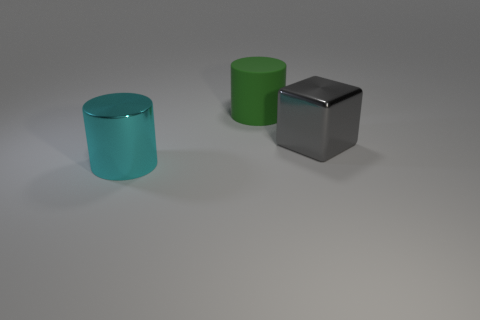What color is the big metal thing that is behind the large metallic cylinder?
Your answer should be very brief. Gray. What shape is the cyan metallic object that is the same size as the gray thing?
Ensure brevity in your answer.  Cylinder. What number of things are large things that are left of the large matte thing or large objects behind the large cyan metal cylinder?
Provide a succinct answer. 3. What material is the green thing that is the same size as the metal block?
Offer a terse response. Rubber. How many other objects are there of the same material as the big gray object?
Give a very brief answer. 1. There is a metallic thing that is on the left side of the big gray cube; is its shape the same as the large green rubber thing behind the big cube?
Offer a terse response. Yes. There is a shiny thing behind the shiny thing that is to the left of the object that is on the right side of the green cylinder; what color is it?
Give a very brief answer. Gray. Is the number of cyan objects less than the number of small purple blocks?
Your answer should be compact. No. What is the color of the large thing that is both on the left side of the gray object and behind the shiny cylinder?
Provide a succinct answer. Green. What is the material of the other object that is the same shape as the big green thing?
Offer a terse response. Metal. 